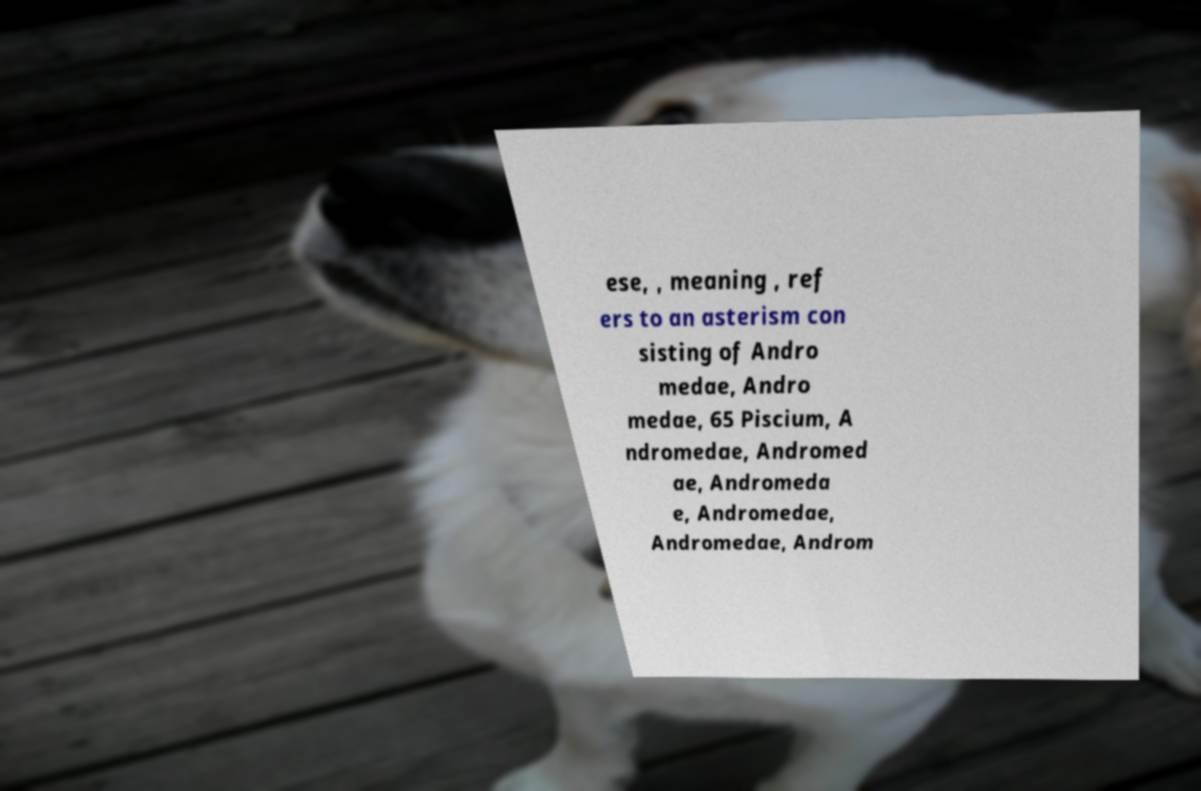Could you assist in decoding the text presented in this image and type it out clearly? ese, , meaning , ref ers to an asterism con sisting of Andro medae, Andro medae, 65 Piscium, A ndromedae, Andromed ae, Andromeda e, Andromedae, Andromedae, Androm 